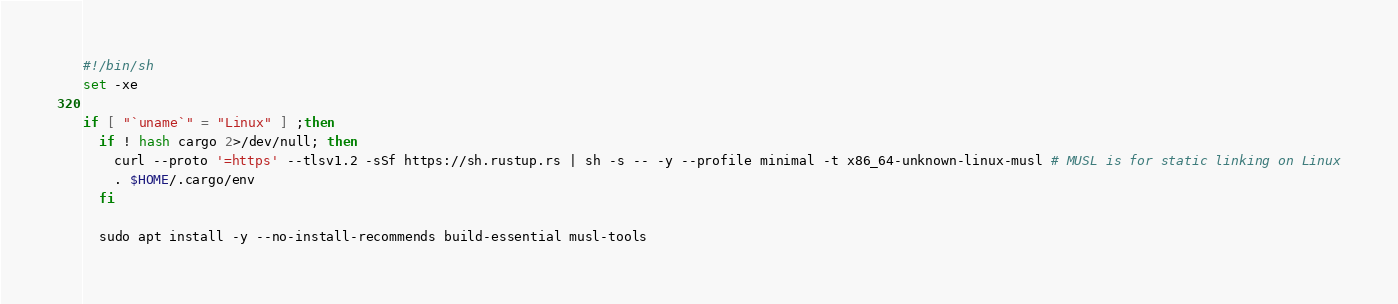<code> <loc_0><loc_0><loc_500><loc_500><_Bash_>#!/bin/sh
set -xe

if [ "`uname`" = "Linux" ] ;then
  if ! hash cargo 2>/dev/null; then
    curl --proto '=https' --tlsv1.2 -sSf https://sh.rustup.rs | sh -s -- -y --profile minimal -t x86_64-unknown-linux-musl # MUSL is for static linking on Linux
    . $HOME/.cargo/env
  fi

  sudo apt install -y --no-install-recommends build-essential musl-tools
</code> 